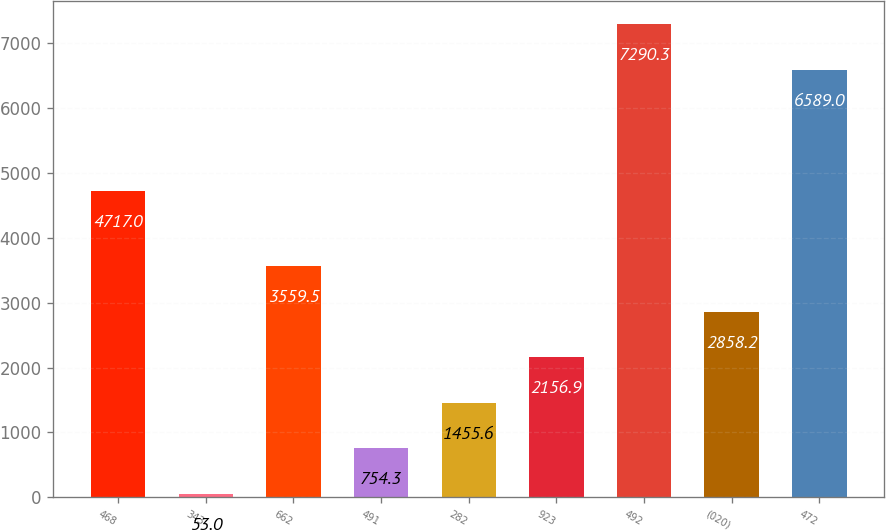Convert chart to OTSL. <chart><loc_0><loc_0><loc_500><loc_500><bar_chart><fcel>468<fcel>343<fcel>662<fcel>491<fcel>282<fcel>923<fcel>492<fcel>(020)<fcel>472<nl><fcel>4717<fcel>53<fcel>3559.5<fcel>754.3<fcel>1455.6<fcel>2156.9<fcel>7290.3<fcel>2858.2<fcel>6589<nl></chart> 